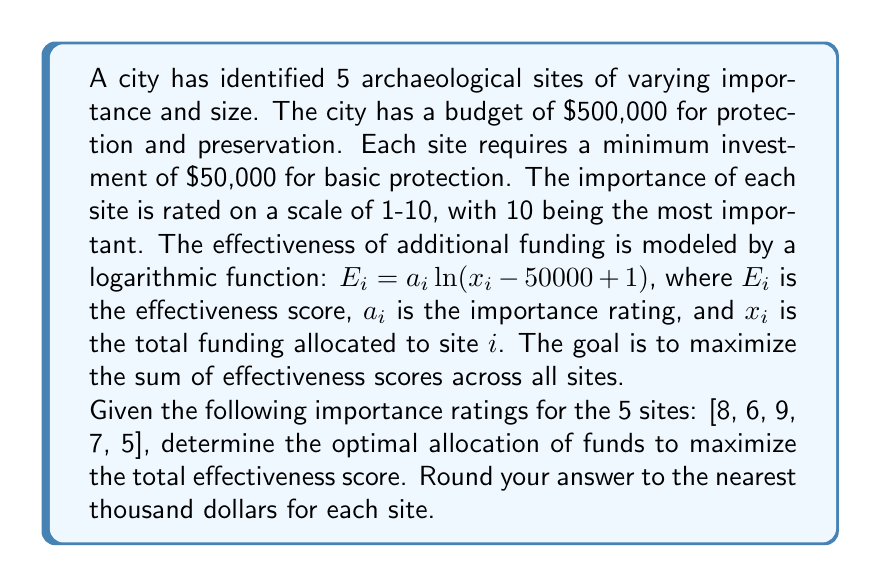Give your solution to this math problem. To solve this problem, we need to use the method of Lagrange multipliers, as we're dealing with a constrained optimization problem. Here's the step-by-step approach:

1) First, let's define our objective function and constraint:

   Objective: Maximize $f(x_1, x_2, x_3, x_4, x_5) = \sum_{i=1}^5 a_i \ln(x_i - 50000 + 1)$
   Constraint: $g(x_1, x_2, x_3, x_4, x_5) = x_1 + x_2 + x_3 + x_4 + x_5 = 500000$

2) We form the Lagrangian function:

   $L(x_1, x_2, x_3, x_4, x_5, \lambda) = f(x_1, x_2, x_3, x_4, x_5) - \lambda g(x_1, x_2, x_3, x_4, x_5)$

3) We take partial derivatives and set them equal to zero:

   $\frac{\partial L}{\partial x_i} = \frac{a_i}{x_i - 50000 + 1} - \lambda = 0$ for $i = 1, 2, 3, 4, 5$

4) Solving these equations:

   $x_i = \frac{a_i}{\lambda} + 49999$ for $i = 1, 2, 3, 4, 5$

5) Substituting into the constraint equation:

   $\sum_{i=1}^5 (\frac{a_i}{\lambda} + 49999) = 500000$

   $\frac{1}{\lambda} \sum_{i=1}^5 a_i + 249995 = 500000$

   $\frac{1}{\lambda} (8 + 6 + 9 + 7 + 5) = 250005$

   $\frac{35}{\lambda} = 250005$

   $\lambda = \frac{35}{250005} \approx 0.00014$

6) Now we can calculate the optimal allocations:

   $x_1 = \frac{8}{0.00014} + 49999 \approx 107,142$
   $x_2 = \frac{6}{0.00014} + 49999 \approx 92,856$
   $x_3 = \frac{9}{0.00014} + 49999 \approx 114,285$
   $x_4 = \frac{7}{0.00014} + 49999 \approx 99,999$
   $x_5 = \frac{5}{0.00014} + 49999 \approx 85,713$

7) Rounding to the nearest thousand:

   $x_1 \approx 107,000$
   $x_2 \approx 93,000$
   $x_3 \approx 114,000$
   $x_4 \approx 100,000$
   $x_5 \approx 86,000$
Answer: The optimal allocation of funds (rounded to the nearest thousand dollars) is:
Site 1: $107,000
Site 2: $93,000
Site 3: $114,000
Site 4: $100,000
Site 5: $86,000 